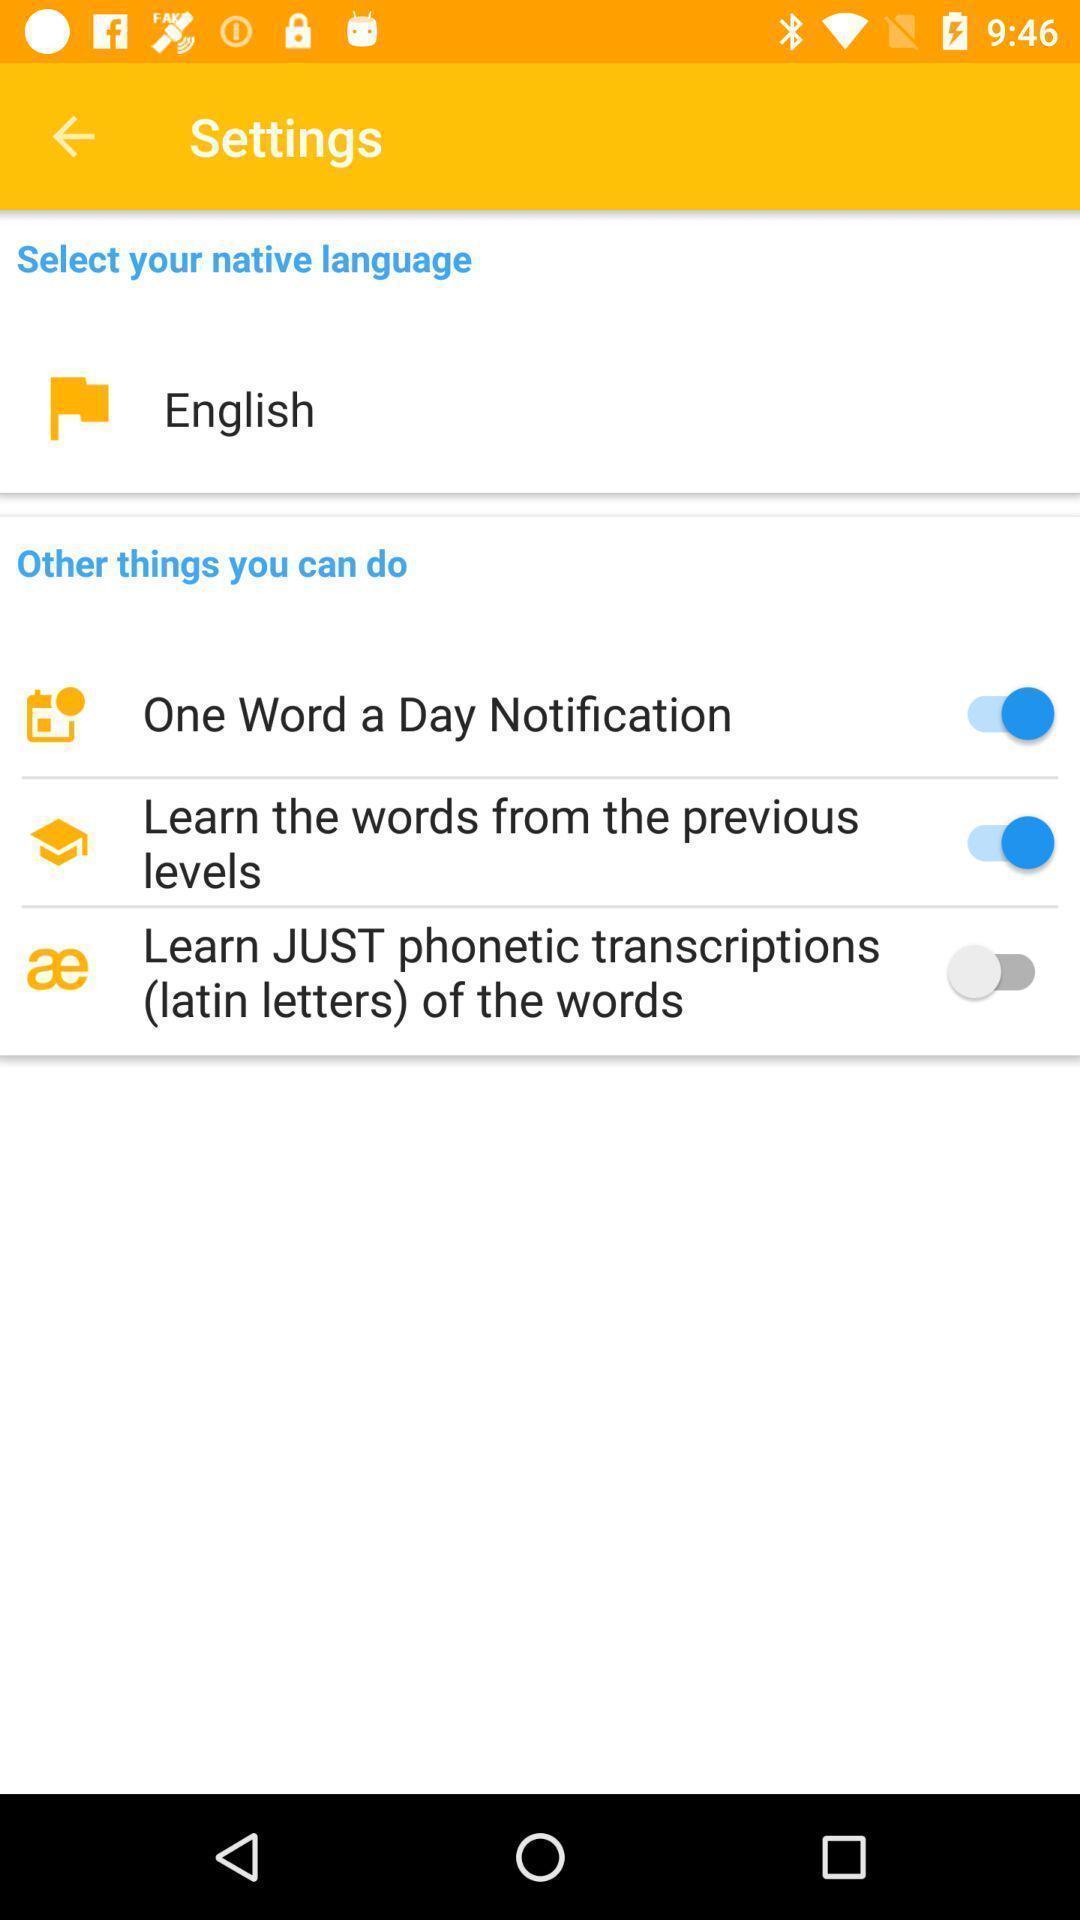Give me a summary of this screen capture. Various types of setting options in the application. 